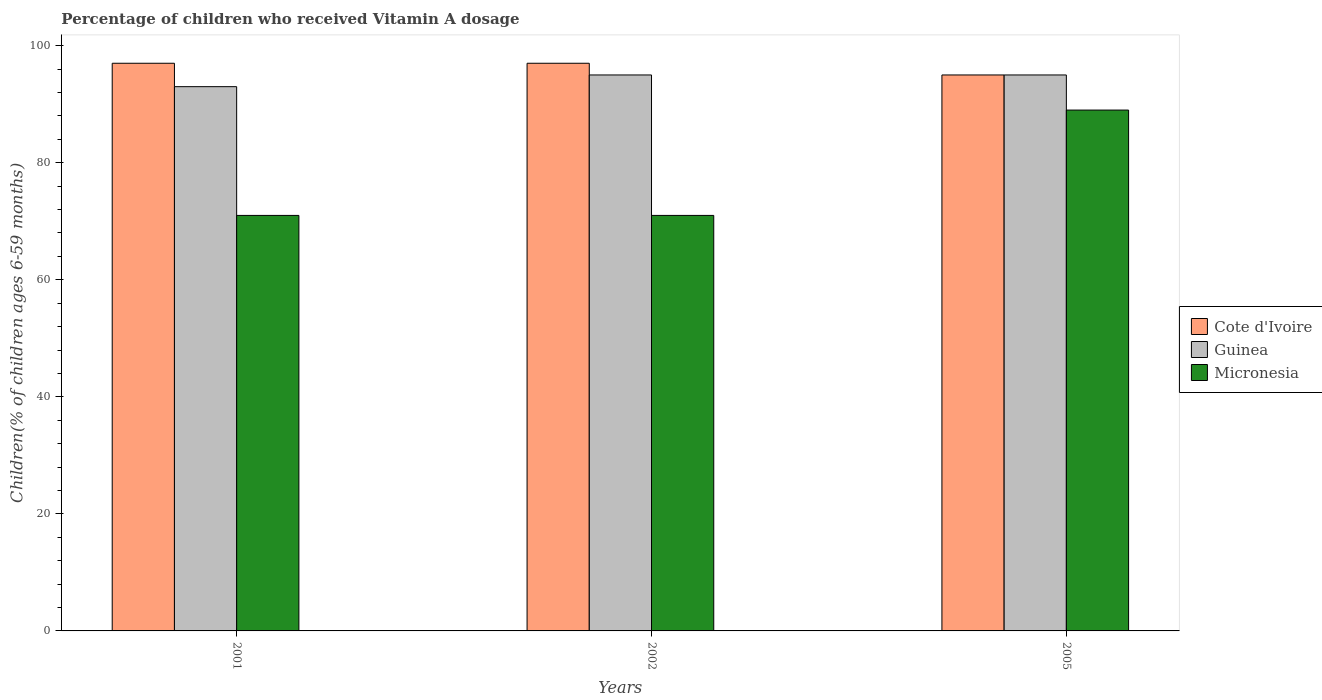How many groups of bars are there?
Your answer should be compact. 3. Are the number of bars on each tick of the X-axis equal?
Your answer should be very brief. Yes. What is the label of the 3rd group of bars from the left?
Your answer should be very brief. 2005. In how many cases, is the number of bars for a given year not equal to the number of legend labels?
Give a very brief answer. 0. What is the percentage of children who received Vitamin A dosage in Guinea in 2001?
Your answer should be very brief. 93. Across all years, what is the maximum percentage of children who received Vitamin A dosage in Micronesia?
Offer a very short reply. 89. Across all years, what is the minimum percentage of children who received Vitamin A dosage in Guinea?
Offer a terse response. 93. In which year was the percentage of children who received Vitamin A dosage in Micronesia maximum?
Offer a terse response. 2005. In which year was the percentage of children who received Vitamin A dosage in Micronesia minimum?
Your answer should be compact. 2001. What is the total percentage of children who received Vitamin A dosage in Cote d'Ivoire in the graph?
Your response must be concise. 289. What is the difference between the percentage of children who received Vitamin A dosage in Guinea in 2001 and that in 2002?
Give a very brief answer. -2. What is the average percentage of children who received Vitamin A dosage in Cote d'Ivoire per year?
Provide a short and direct response. 96.33. What is the ratio of the percentage of children who received Vitamin A dosage in Micronesia in 2001 to that in 2005?
Ensure brevity in your answer.  0.8. Is the difference between the percentage of children who received Vitamin A dosage in Micronesia in 2001 and 2005 greater than the difference between the percentage of children who received Vitamin A dosage in Guinea in 2001 and 2005?
Your answer should be compact. No. What is the difference between the highest and the lowest percentage of children who received Vitamin A dosage in Micronesia?
Your answer should be very brief. 18. What does the 3rd bar from the left in 2005 represents?
Give a very brief answer. Micronesia. What does the 3rd bar from the right in 2002 represents?
Your answer should be very brief. Cote d'Ivoire. How many bars are there?
Give a very brief answer. 9. Are all the bars in the graph horizontal?
Provide a succinct answer. No. How many years are there in the graph?
Provide a succinct answer. 3. Are the values on the major ticks of Y-axis written in scientific E-notation?
Provide a succinct answer. No. Does the graph contain any zero values?
Provide a succinct answer. No. Does the graph contain grids?
Make the answer very short. No. How are the legend labels stacked?
Keep it short and to the point. Vertical. What is the title of the graph?
Ensure brevity in your answer.  Percentage of children who received Vitamin A dosage. Does "Ukraine" appear as one of the legend labels in the graph?
Provide a short and direct response. No. What is the label or title of the X-axis?
Offer a very short reply. Years. What is the label or title of the Y-axis?
Your answer should be compact. Children(% of children ages 6-59 months). What is the Children(% of children ages 6-59 months) of Cote d'Ivoire in 2001?
Ensure brevity in your answer.  97. What is the Children(% of children ages 6-59 months) of Guinea in 2001?
Keep it short and to the point. 93. What is the Children(% of children ages 6-59 months) in Micronesia in 2001?
Keep it short and to the point. 71. What is the Children(% of children ages 6-59 months) in Cote d'Ivoire in 2002?
Provide a short and direct response. 97. What is the Children(% of children ages 6-59 months) in Cote d'Ivoire in 2005?
Offer a very short reply. 95. What is the Children(% of children ages 6-59 months) of Micronesia in 2005?
Give a very brief answer. 89. Across all years, what is the maximum Children(% of children ages 6-59 months) of Cote d'Ivoire?
Your answer should be compact. 97. Across all years, what is the maximum Children(% of children ages 6-59 months) of Micronesia?
Offer a terse response. 89. Across all years, what is the minimum Children(% of children ages 6-59 months) in Cote d'Ivoire?
Offer a terse response. 95. Across all years, what is the minimum Children(% of children ages 6-59 months) of Guinea?
Make the answer very short. 93. Across all years, what is the minimum Children(% of children ages 6-59 months) in Micronesia?
Keep it short and to the point. 71. What is the total Children(% of children ages 6-59 months) of Cote d'Ivoire in the graph?
Your answer should be compact. 289. What is the total Children(% of children ages 6-59 months) of Guinea in the graph?
Provide a short and direct response. 283. What is the total Children(% of children ages 6-59 months) of Micronesia in the graph?
Offer a terse response. 231. What is the difference between the Children(% of children ages 6-59 months) in Guinea in 2001 and that in 2005?
Give a very brief answer. -2. What is the difference between the Children(% of children ages 6-59 months) in Micronesia in 2001 and that in 2005?
Offer a very short reply. -18. What is the difference between the Children(% of children ages 6-59 months) of Cote d'Ivoire in 2002 and that in 2005?
Your answer should be compact. 2. What is the difference between the Children(% of children ages 6-59 months) of Guinea in 2002 and that in 2005?
Ensure brevity in your answer.  0. What is the difference between the Children(% of children ages 6-59 months) of Guinea in 2001 and the Children(% of children ages 6-59 months) of Micronesia in 2002?
Provide a succinct answer. 22. What is the difference between the Children(% of children ages 6-59 months) of Cote d'Ivoire in 2001 and the Children(% of children ages 6-59 months) of Guinea in 2005?
Your answer should be compact. 2. What is the difference between the Children(% of children ages 6-59 months) in Guinea in 2001 and the Children(% of children ages 6-59 months) in Micronesia in 2005?
Your answer should be compact. 4. What is the difference between the Children(% of children ages 6-59 months) in Cote d'Ivoire in 2002 and the Children(% of children ages 6-59 months) in Micronesia in 2005?
Offer a very short reply. 8. What is the difference between the Children(% of children ages 6-59 months) in Guinea in 2002 and the Children(% of children ages 6-59 months) in Micronesia in 2005?
Offer a terse response. 6. What is the average Children(% of children ages 6-59 months) in Cote d'Ivoire per year?
Provide a succinct answer. 96.33. What is the average Children(% of children ages 6-59 months) of Guinea per year?
Give a very brief answer. 94.33. What is the average Children(% of children ages 6-59 months) in Micronesia per year?
Keep it short and to the point. 77. In the year 2001, what is the difference between the Children(% of children ages 6-59 months) of Cote d'Ivoire and Children(% of children ages 6-59 months) of Guinea?
Offer a very short reply. 4. In the year 2002, what is the difference between the Children(% of children ages 6-59 months) in Guinea and Children(% of children ages 6-59 months) in Micronesia?
Give a very brief answer. 24. In the year 2005, what is the difference between the Children(% of children ages 6-59 months) in Cote d'Ivoire and Children(% of children ages 6-59 months) in Guinea?
Give a very brief answer. 0. In the year 2005, what is the difference between the Children(% of children ages 6-59 months) in Cote d'Ivoire and Children(% of children ages 6-59 months) in Micronesia?
Make the answer very short. 6. What is the ratio of the Children(% of children ages 6-59 months) in Guinea in 2001 to that in 2002?
Provide a short and direct response. 0.98. What is the ratio of the Children(% of children ages 6-59 months) in Micronesia in 2001 to that in 2002?
Make the answer very short. 1. What is the ratio of the Children(% of children ages 6-59 months) of Cote d'Ivoire in 2001 to that in 2005?
Make the answer very short. 1.02. What is the ratio of the Children(% of children ages 6-59 months) of Guinea in 2001 to that in 2005?
Your response must be concise. 0.98. What is the ratio of the Children(% of children ages 6-59 months) in Micronesia in 2001 to that in 2005?
Ensure brevity in your answer.  0.8. What is the ratio of the Children(% of children ages 6-59 months) in Cote d'Ivoire in 2002 to that in 2005?
Keep it short and to the point. 1.02. What is the ratio of the Children(% of children ages 6-59 months) in Micronesia in 2002 to that in 2005?
Provide a succinct answer. 0.8. What is the difference between the highest and the second highest Children(% of children ages 6-59 months) of Guinea?
Your response must be concise. 0. What is the difference between the highest and the lowest Children(% of children ages 6-59 months) of Guinea?
Offer a very short reply. 2. What is the difference between the highest and the lowest Children(% of children ages 6-59 months) in Micronesia?
Make the answer very short. 18. 